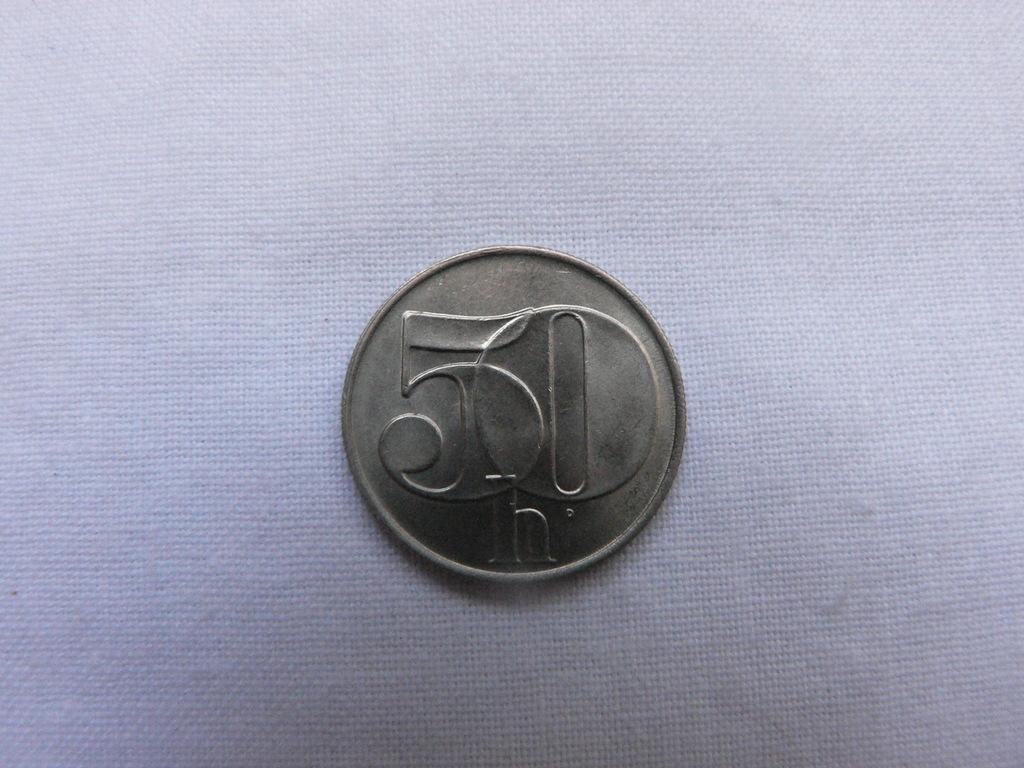<image>
Write a terse but informative summary of the picture. Silver coin with a giant number "50" on it. 